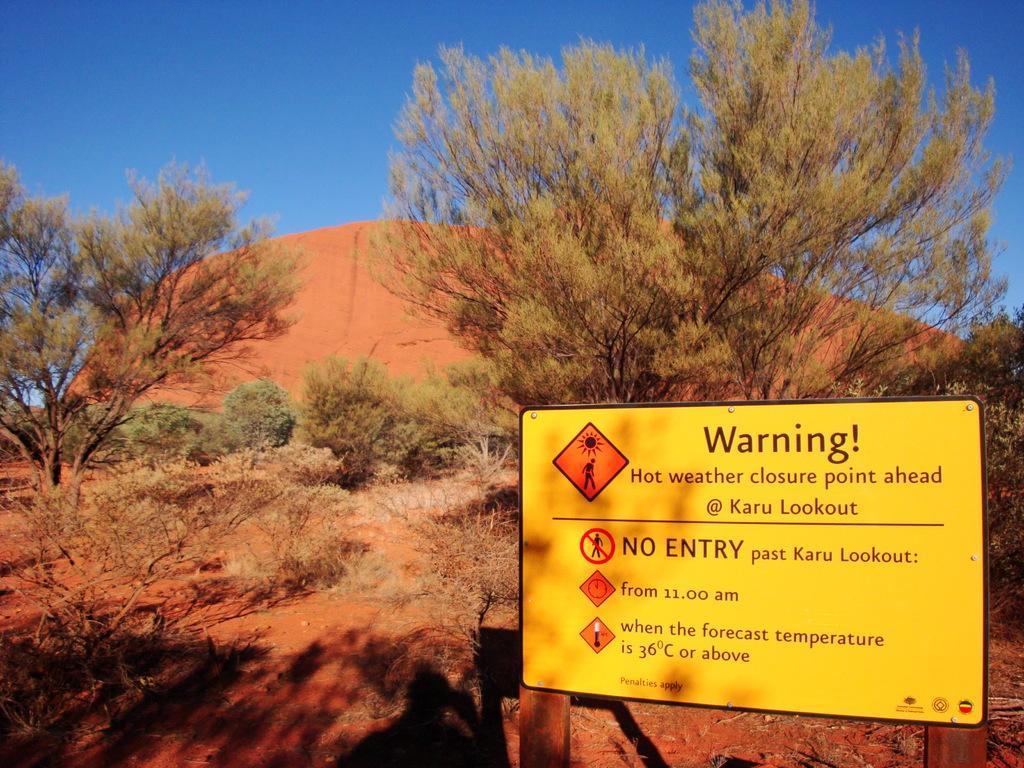Can you describe this image briefly? In this picture I can see trees and plants on the ground. Here I can see a yellow color board on which something written on it. In the background I can see the sky. 